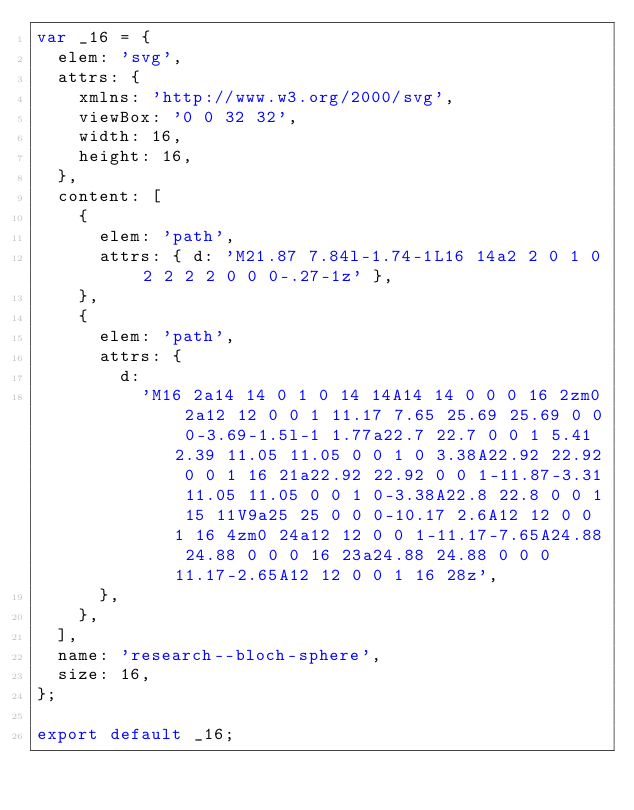<code> <loc_0><loc_0><loc_500><loc_500><_JavaScript_>var _16 = {
  elem: 'svg',
  attrs: {
    xmlns: 'http://www.w3.org/2000/svg',
    viewBox: '0 0 32 32',
    width: 16,
    height: 16,
  },
  content: [
    {
      elem: 'path',
      attrs: { d: 'M21.87 7.84l-1.74-1L16 14a2 2 0 1 0 2 2 2 2 0 0 0-.27-1z' },
    },
    {
      elem: 'path',
      attrs: {
        d:
          'M16 2a14 14 0 1 0 14 14A14 14 0 0 0 16 2zm0 2a12 12 0 0 1 11.17 7.65 25.69 25.69 0 0 0-3.69-1.5l-1 1.77a22.7 22.7 0 0 1 5.41 2.39 11.05 11.05 0 0 1 0 3.38A22.92 22.92 0 0 1 16 21a22.92 22.92 0 0 1-11.87-3.31 11.05 11.05 0 0 1 0-3.38A22.8 22.8 0 0 1 15 11V9a25 25 0 0 0-10.17 2.6A12 12 0 0 1 16 4zm0 24a12 12 0 0 1-11.17-7.65A24.88 24.88 0 0 0 16 23a24.88 24.88 0 0 0 11.17-2.65A12 12 0 0 1 16 28z',
      },
    },
  ],
  name: 'research--bloch-sphere',
  size: 16,
};

export default _16;
</code> 